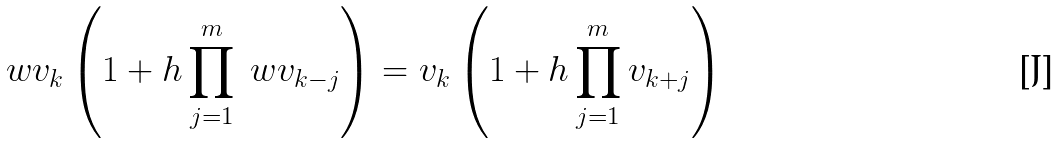<formula> <loc_0><loc_0><loc_500><loc_500>\ w v _ { k } \left ( 1 + h \prod _ { j = 1 } ^ { m } \ w v _ { k - j } \right ) = v _ { k } \left ( 1 + h \prod _ { j = 1 } ^ { m } v _ { k + j } \right )</formula> 